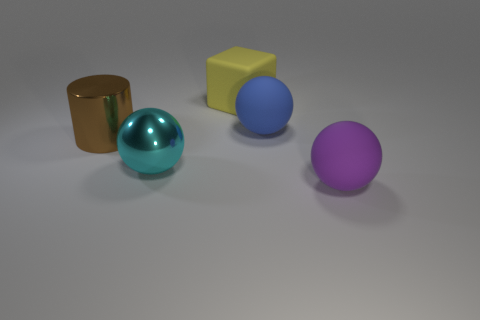Are the big cylinder and the purple sphere made of the same material?
Make the answer very short. No. There is a large object that is both on the left side of the yellow matte cube and behind the big cyan thing; what color is it?
Provide a short and direct response. Brown. Are there any blue blocks of the same size as the shiny ball?
Provide a succinct answer. No. What is the size of the rubber thing that is on the right side of the blue rubber ball that is behind the metal cylinder?
Make the answer very short. Large. Is the number of big cyan objects that are behind the yellow block less than the number of large rubber spheres?
Keep it short and to the point. Yes. Do the large cylinder and the big matte block have the same color?
Offer a very short reply. No. How big is the block?
Give a very brief answer. Large. How many big things are the same color as the big cylinder?
Your answer should be compact. 0. Are there any yellow blocks that are in front of the rubber thing that is on the left side of the large blue thing to the right of the brown cylinder?
Give a very brief answer. No. What is the shape of the yellow object that is the same size as the purple rubber object?
Your response must be concise. Cube. 